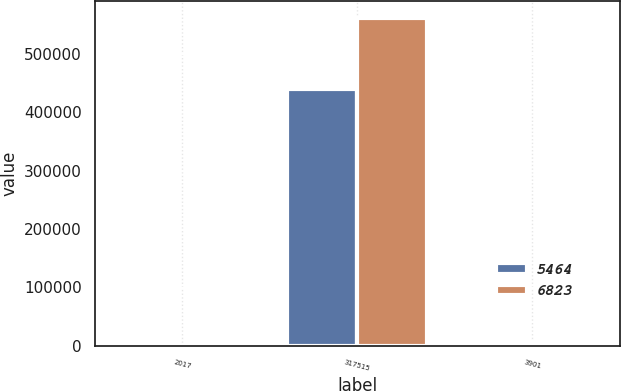Convert chart to OTSL. <chart><loc_0><loc_0><loc_500><loc_500><stacked_bar_chart><ecel><fcel>2017<fcel>317515<fcel>3901<nl><fcel>5464<fcel>2016<fcel>439667<fcel>5464<nl><fcel>6823<fcel>2015<fcel>562649<fcel>6823<nl></chart> 